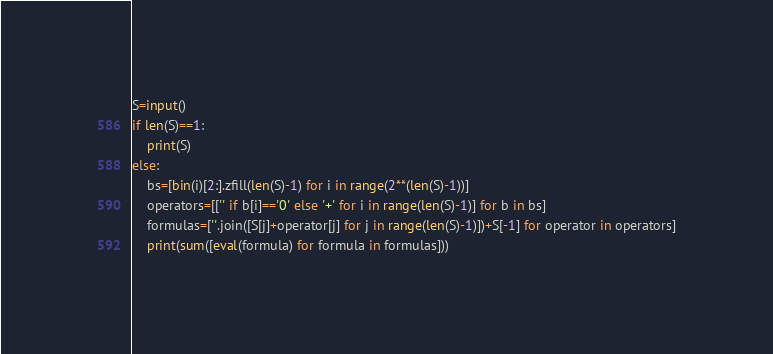Convert code to text. <code><loc_0><loc_0><loc_500><loc_500><_Python_>S=input()
if len(S)==1:
    print(S)
else:
    bs=[bin(i)[2:].zfill(len(S)-1) for i in range(2**(len(S)-1))]
    operators=[['' if b[i]=='0' else '+' for i in range(len(S)-1)] for b in bs]
    formulas=[''.join([S[j]+operator[j] for j in range(len(S)-1)])+S[-1] for operator in operators]
    print(sum([eval(formula) for formula in formulas]))</code> 